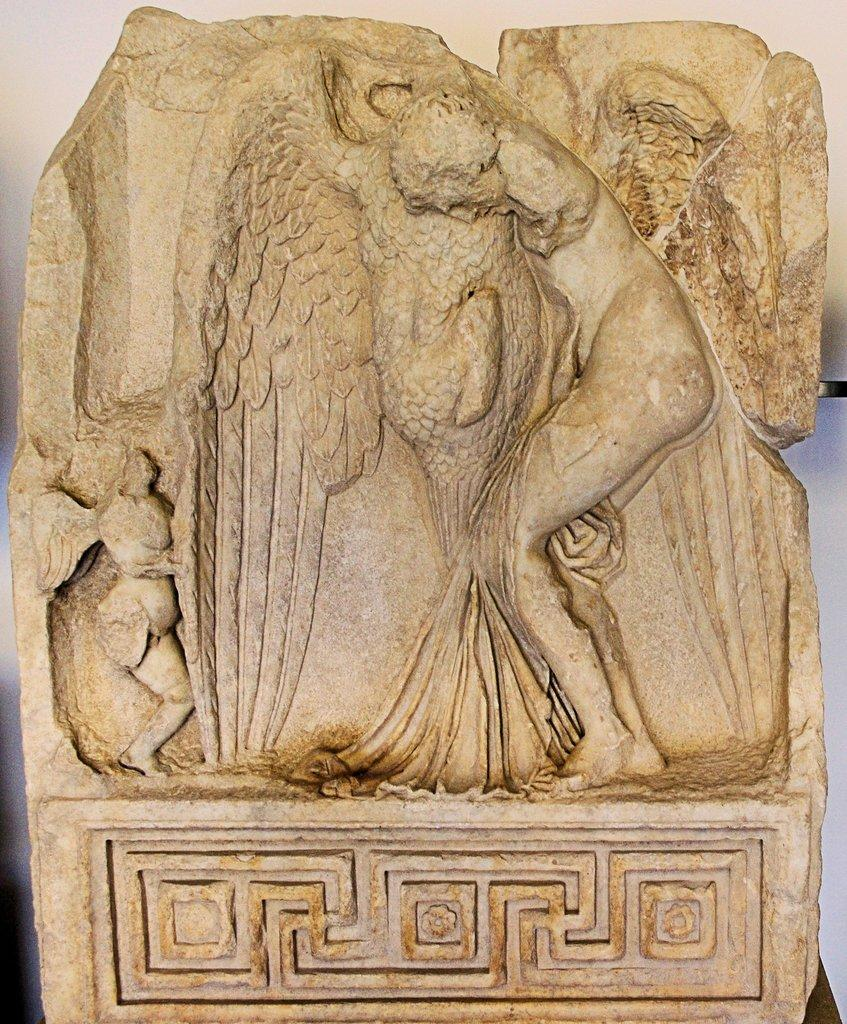What is the main subject in the image? There is a statue in the image. What color is the background of the image? The background of the image is white. What type of coach can be seen in the image? There is no coach present in the image; it features a statue and a white background. What is the base of the statue made of in the image? The provided facts do not mention the material or base of the statue, so it cannot be determined from the image. 